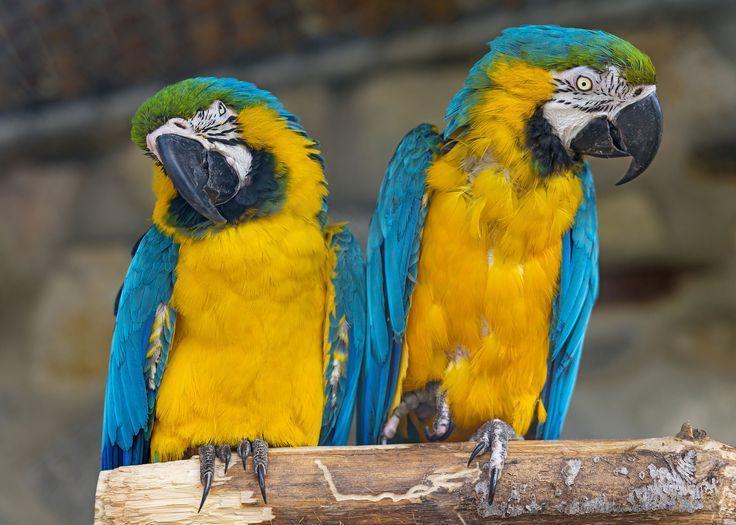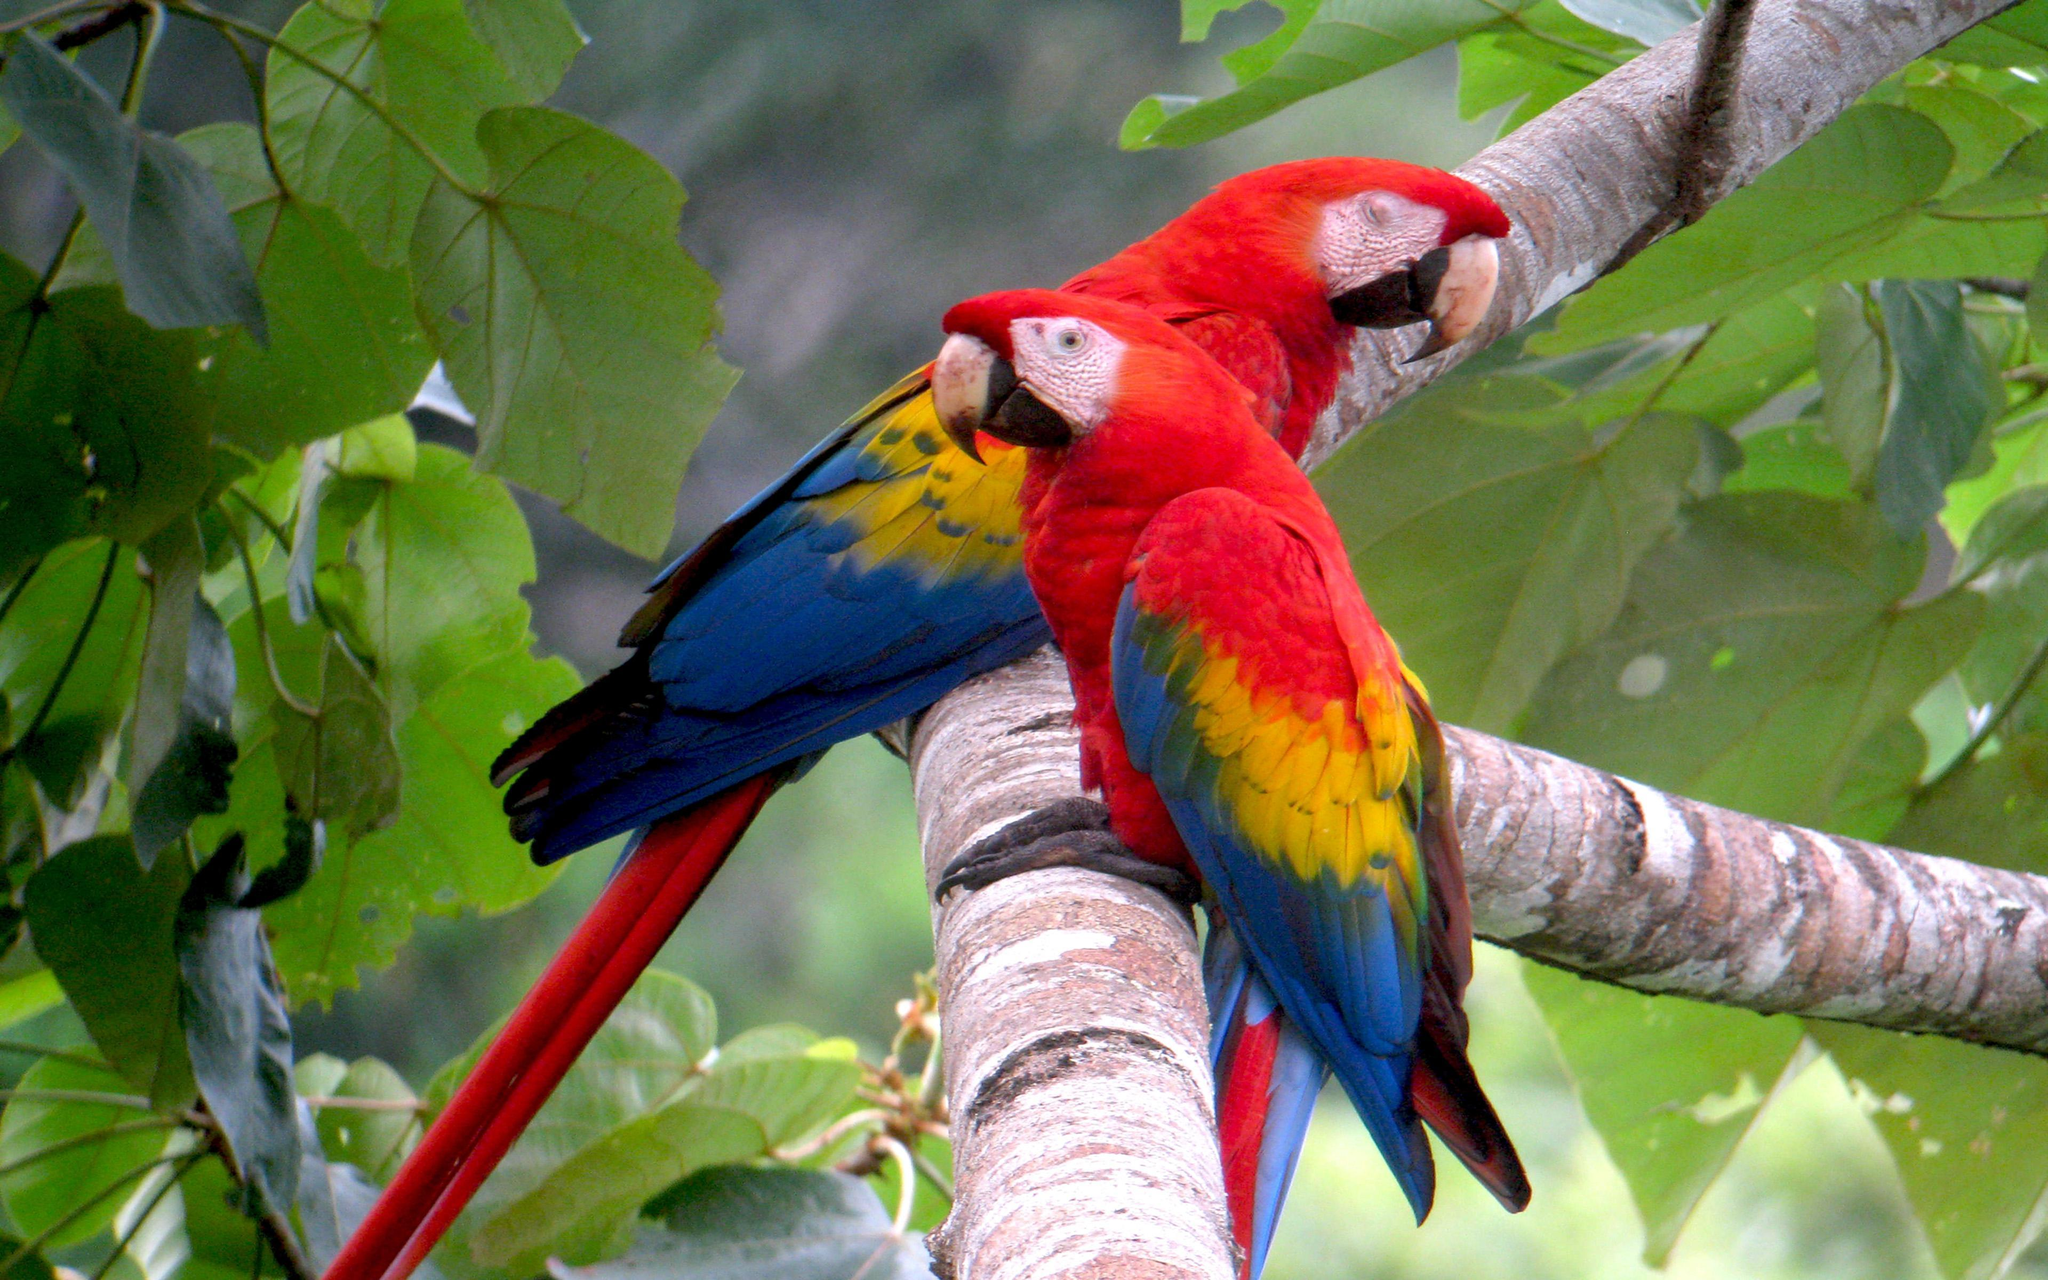The first image is the image on the left, the second image is the image on the right. For the images displayed, is the sentence "One image shows two solid-blue parrots perched on a branch, and the other image shows one red-headed bird next to a blue-and-yellow bird." factually correct? Answer yes or no. No. 